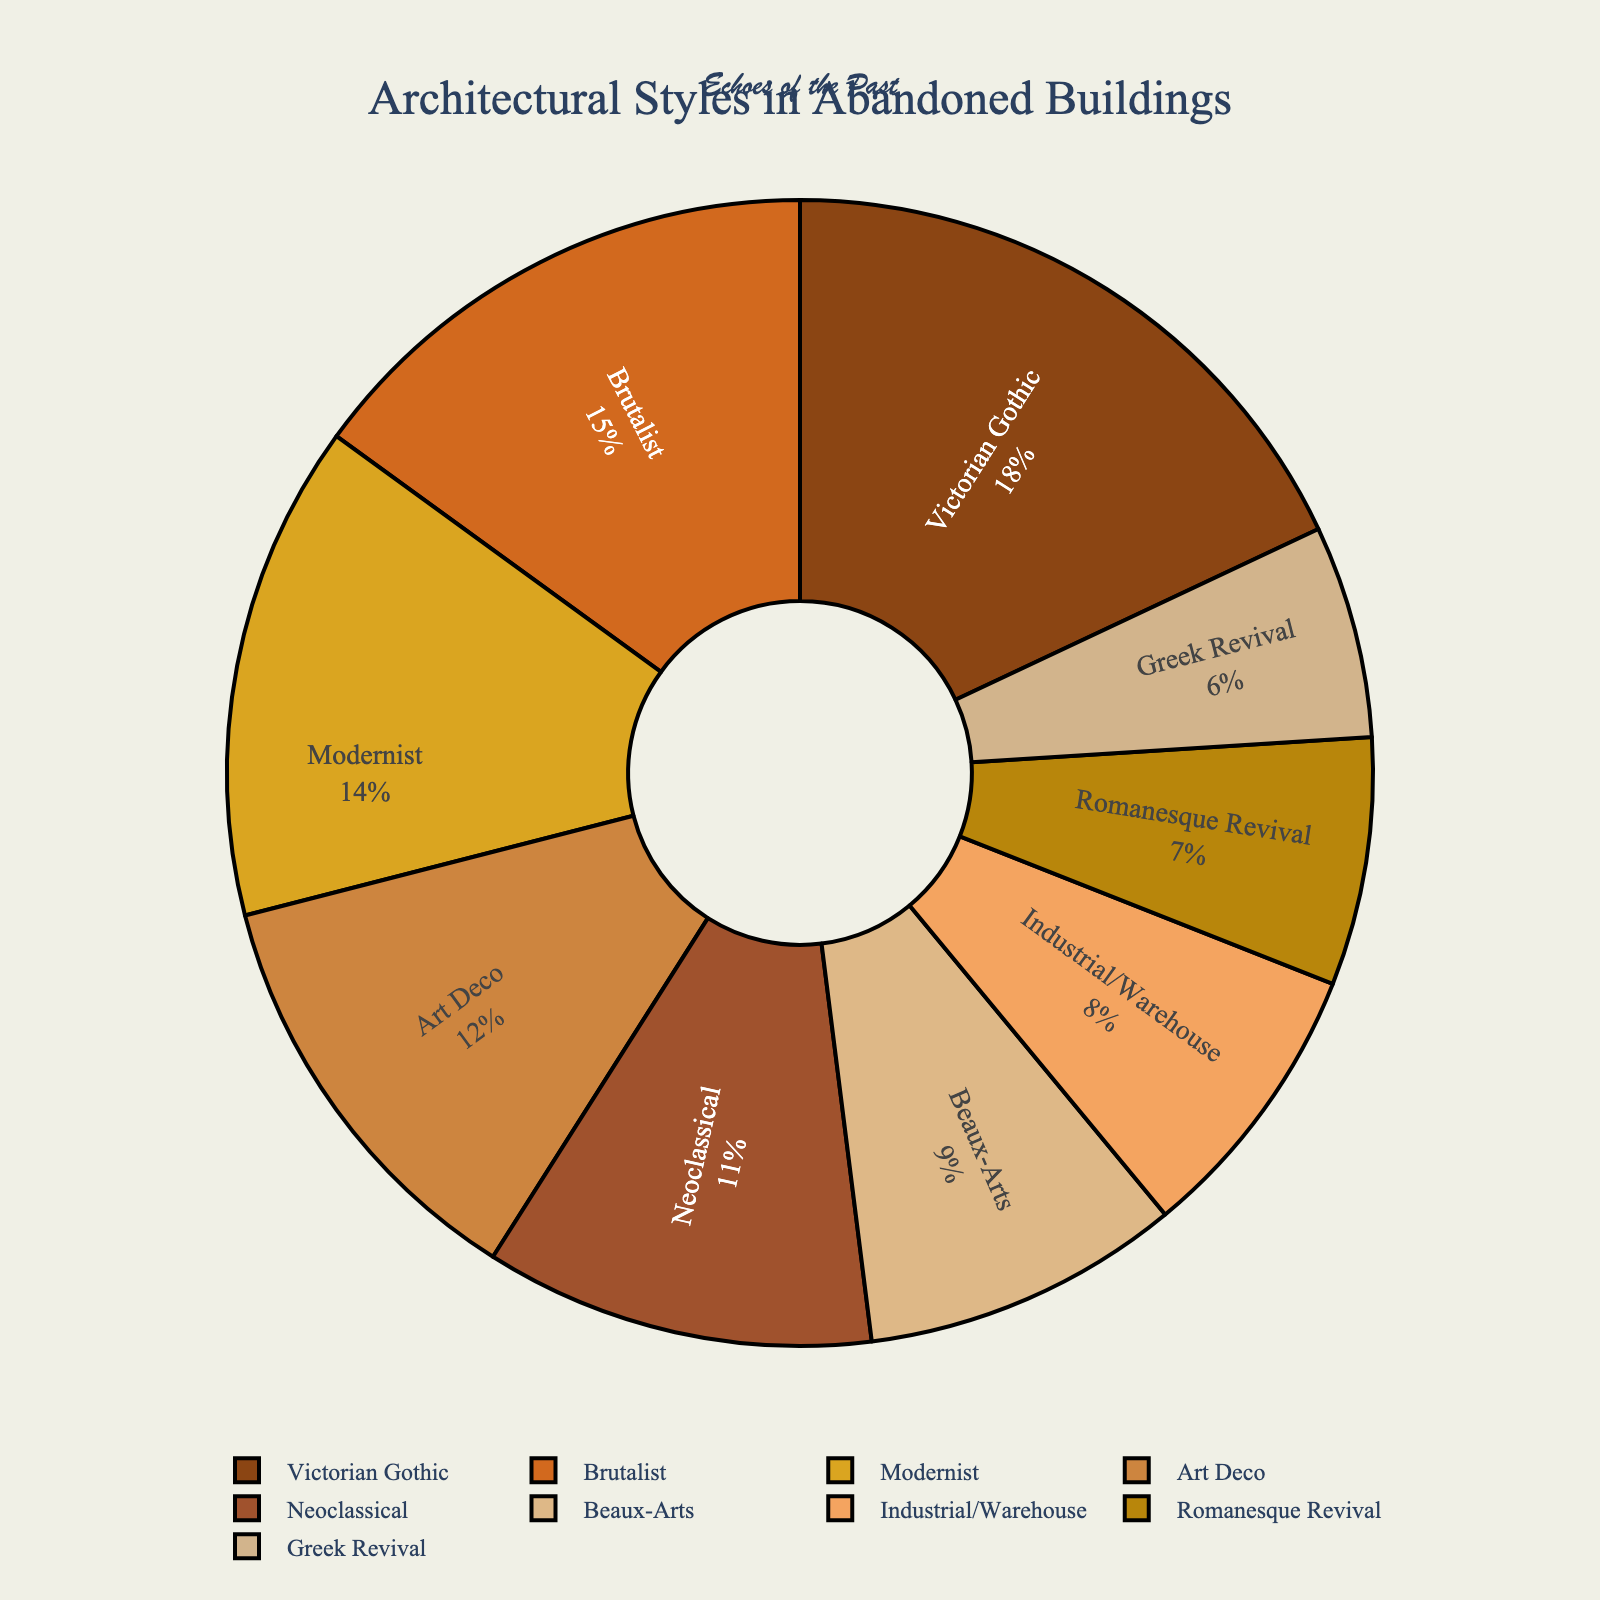Which architectural style has the highest percentage in abandoned buildings? The pie chart shows various architectural styles with their respective percentages. The slice representing "Victorian Gothic" is the largest, indicating it has the highest percentage at 18%.
Answer: Victorian Gothic What is the combined percentage of Brutalist and Modernist styles? The percentages are provided for each architectural style. Brutalist accounts for 15% and Modernist accounts for 14%. Adding these two (15% + 14%) gives a combined percentage of 29%.
Answer: 29% Which architectural style has the least representation in abandoned buildings? By examining the slices of the pie chart, the "Greek Revival" style has the smallest slice, indicating it has the lowest percentage at 6%.
Answer: Greek Revival How does the percentage of Art Deco compare to Neoclassical? From the pie chart, Art Deco accounts for 12% and Neoclassical accounts for 11%. Comparatively, Art Deco has a slightly higher percentage by 1%.
Answer: Art Deco has a higher percentage What is the total percentage of Victorian Gothic, Beaux-Arts, and Romanesque Revival styles combined? The percentages for these styles are 18% (Victorian Gothic), 9% (Beaux-Arts), and 7% (Romanesque Revival). Their combined percentage is 18% + 9% + 7% = 34%.
Answer: 34% Which two styles combined account for almost one-third of the total percentage? One-third of 100% is approximately 33%. From the pie chart, Brutalist (15%) and Modernist (14%) together contribute 29%, which is closest but not enough. Victorian Gothic (18%) and Art Deco (12%) combined make 30%, which is closer.
Answer: Victorian Gothic and Art Deco Which style occupies a slice with a color lighter than Art Deco's, but darker than Greek Revival's? The colors of the slices range from darker shades to lighter ones. From the pie chart, Neoclassical is shown in a color that fits this description. It is lighter than Art Deco's color and darker than Greek Revival's color.
Answer: Neoclassical By what percentage does Victorian Gothic exceed Industrial/Warehouse style? Victorian Gothic has 18% and Industrial/Warehouse has 8%. The percentage difference is calculated by subtracting 8% from 18% (18% - 8%).
Answer: 10% What is the difference in percentage between the second-largest and second-smallest slices, and which styles do they represent? The second-largest slice is Modernist with 14% and the second-smallest is Beaux-Arts with 9%. The percentage difference is 14% - 9% = 5%.
Answer: 5% What proportion of the architectural styles is represented by Romanesque Revival and Greek Revival? Romanesque Revival represents 7% and Greek Revival 6%. Adding these (7% + 6%) gives 13%, out of the total 100%.
Answer: 13% 